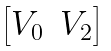Convert formula to latex. <formula><loc_0><loc_0><loc_500><loc_500>\begin{bmatrix} V _ { 0 } & V _ { 2 } \end{bmatrix}</formula> 